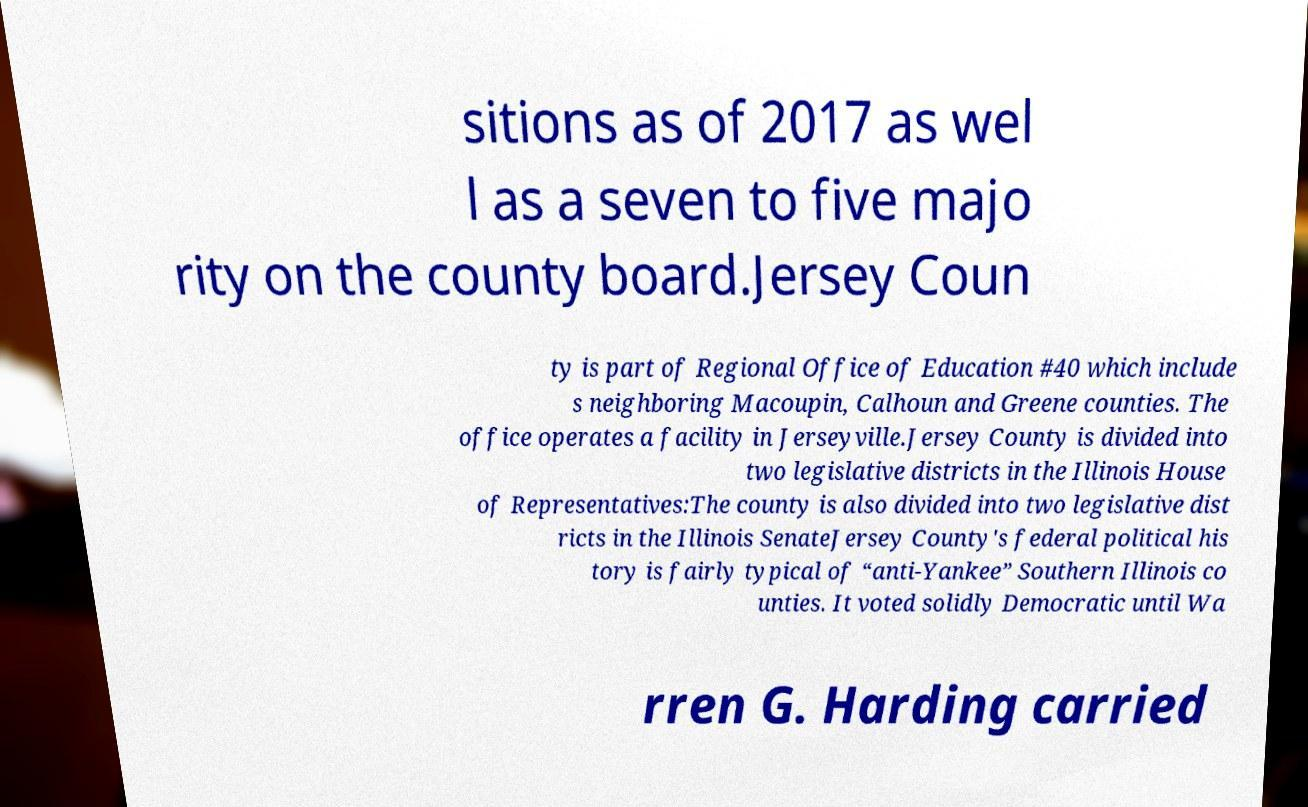For documentation purposes, I need the text within this image transcribed. Could you provide that? sitions as of 2017 as wel l as a seven to five majo rity on the county board.Jersey Coun ty is part of Regional Office of Education #40 which include s neighboring Macoupin, Calhoun and Greene counties. The office operates a facility in Jerseyville.Jersey County is divided into two legislative districts in the Illinois House of Representatives:The county is also divided into two legislative dist ricts in the Illinois SenateJersey County's federal political his tory is fairly typical of “anti-Yankee” Southern Illinois co unties. It voted solidly Democratic until Wa rren G. Harding carried 